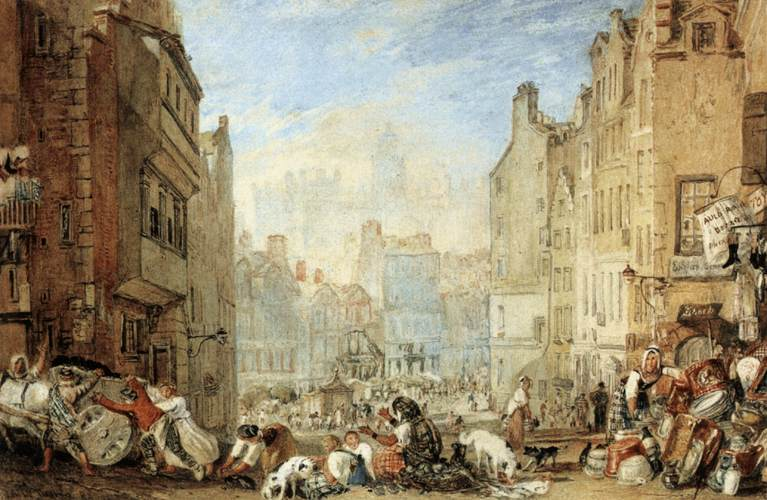What significance does this painting have in terms of historical or social context? This painting may be significant in exploring the social fabric of the time it represents. It provides insights into daily life, social hierarchy, and urban living. The busy market scene with diverse activities and interactions highlights the communal aspects of life in that era. Furthermore, the architecture suggests a town that has grown organically, with buildings from various periods, signifying economic and historical developments. Paintings like these can serve as visual documents that inform us about the fashion, livelihoods, and urban design of the period, offering a rich tapestry for historical and sociological study. 